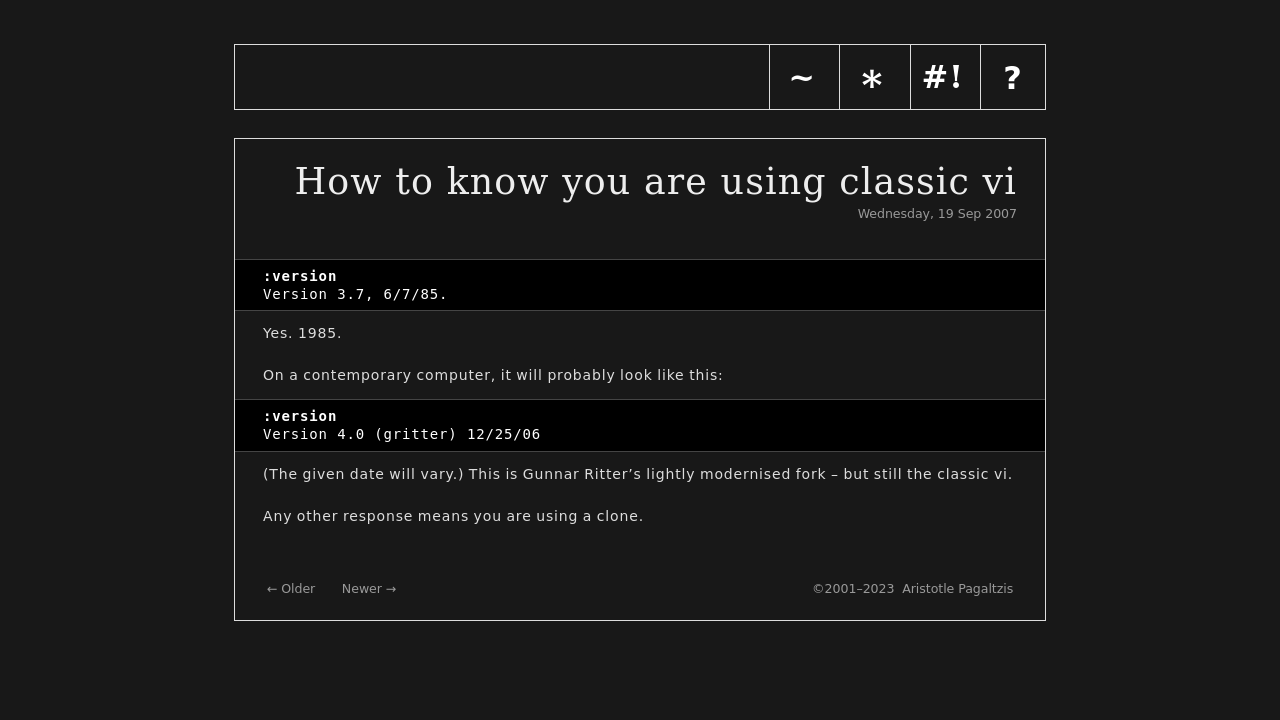Can you explain why the navigation bar includes the specific items shown? The navigation items 'Home', 'Archive', 'Code', and 'About' represent essential elements of a typical informational or blog site. 'Home' likely returns visitors to the main page, 'Archive' provides historical access to past content, 'Code' might relate to programming or software insights related to vi, and 'About' gives background on the site or the author. This structured navigation aids users in efficiently finding the information they need, enhancing the user experience. 